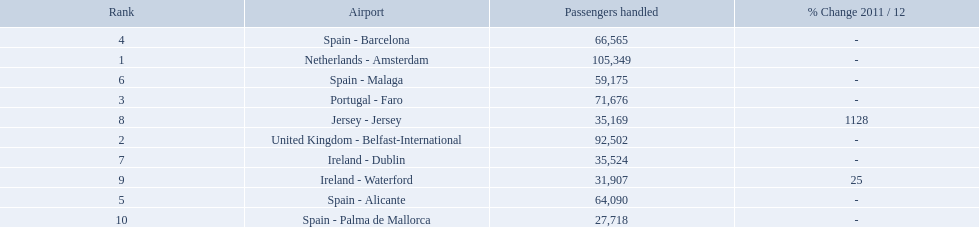What is the highest number of passengers handled? 105,349. What is the destination of the passengers leaving the area that handles 105,349 travellers? Netherlands - Amsterdam. What are all of the airports? Netherlands - Amsterdam, United Kingdom - Belfast-International, Portugal - Faro, Spain - Barcelona, Spain - Alicante, Spain - Malaga, Ireland - Dublin, Jersey - Jersey, Ireland - Waterford, Spain - Palma de Mallorca. How many passengers have they handled? 105,349, 92,502, 71,676, 66,565, 64,090, 59,175, 35,524, 35,169, 31,907, 27,718. And which airport has handled the most passengers? Netherlands - Amsterdam. 